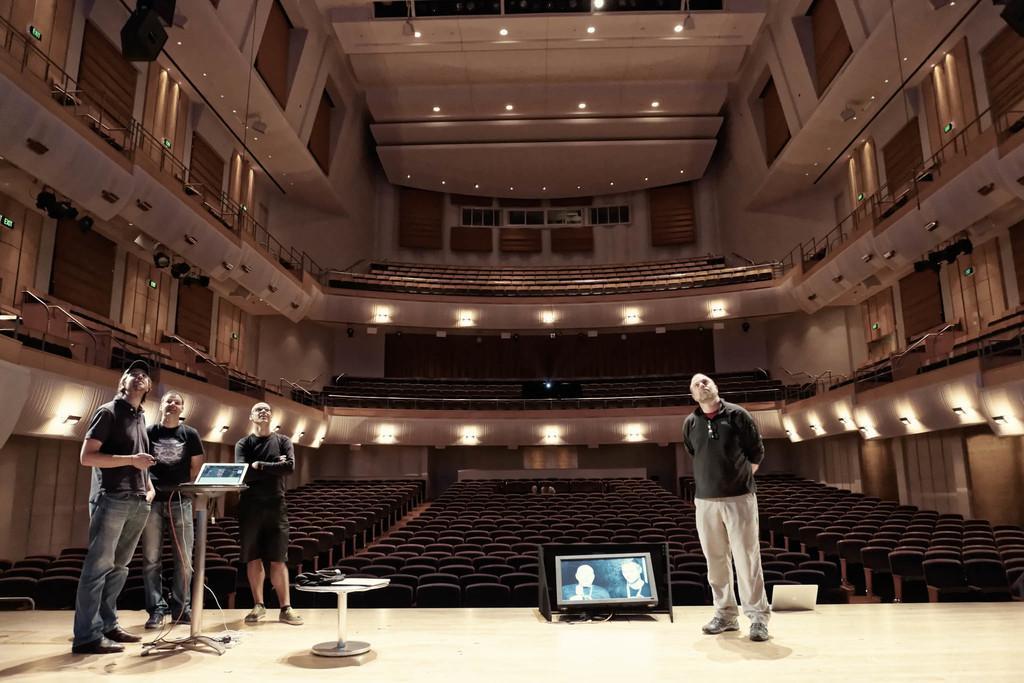Describe this image in one or two sentences. In this picture we can see few people, they are standing, in the left side of the given image we can see a laptop on the table, in the middle of the given image we can find a monitor, in the background we can see few chairs and lights. 